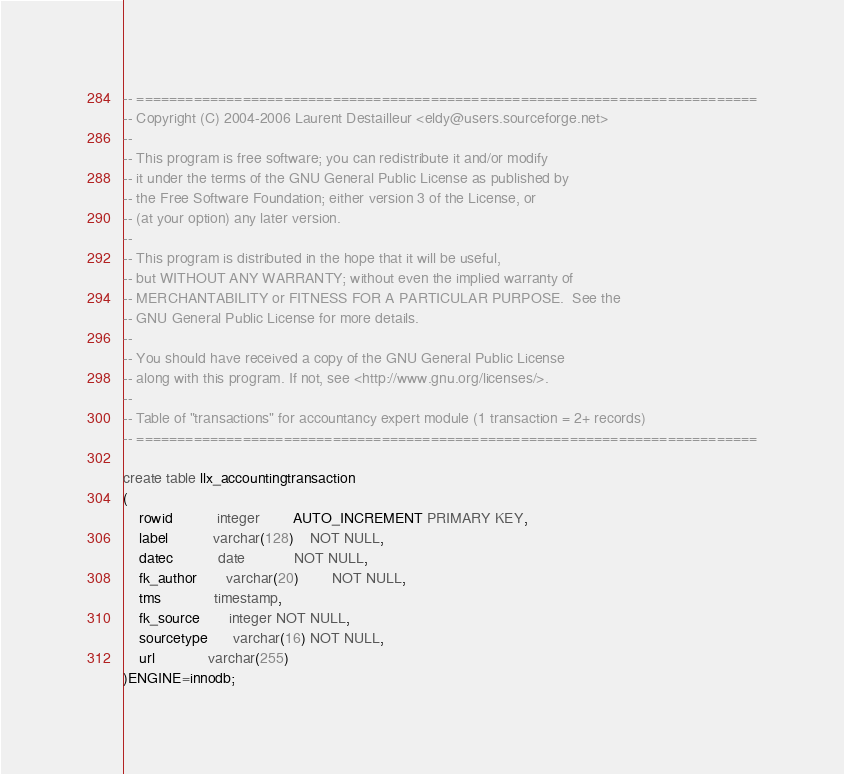Convert code to text. <code><loc_0><loc_0><loc_500><loc_500><_SQL_>-- ============================================================================
-- Copyright (C) 2004-2006 Laurent Destailleur <eldy@users.sourceforge.net>
--
-- This program is free software; you can redistribute it and/or modify
-- it under the terms of the GNU General Public License as published by
-- the Free Software Foundation; either version 3 of the License, or
-- (at your option) any later version.
--
-- This program is distributed in the hope that it will be useful,
-- but WITHOUT ANY WARRANTY; without even the implied warranty of
-- MERCHANTABILITY or FITNESS FOR A PARTICULAR PURPOSE.  See the
-- GNU General Public License for more details.
--
-- You should have received a copy of the GNU General Public License
-- along with this program. If not, see <http://www.gnu.org/licenses/>.
--
-- Table of "transactions" for accountancy expert module (1 transaction = 2+ records)
-- ============================================================================

create table llx_accountingtransaction
(
	rowid           integer 		AUTO_INCREMENT PRIMARY KEY,
	label           varchar(128)    NOT NULL,
	datec           date 			NOT NULL,
	fk_author       varchar(20)		NOT NULL,
	tms             timestamp,
    fk_source       integer NOT NULL,
    sourcetype      varchar(16) NOT NULL,
    url             varchar(255)
)ENGINE=innodb;
</code> 